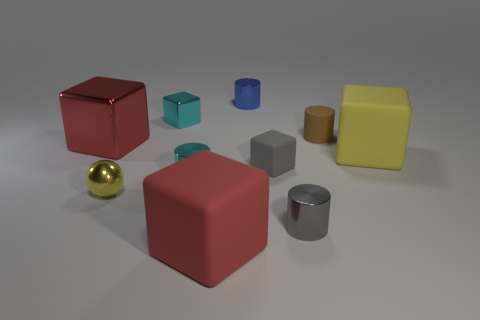Subtract all yellow cylinders. How many red cubes are left? 2 Subtract all small metallic cubes. How many cubes are left? 4 Subtract all blue cylinders. How many cylinders are left? 3 Subtract all cylinders. How many objects are left? 6 Subtract all blue cubes. Subtract all yellow spheres. How many cubes are left? 5 Subtract all red metallic blocks. Subtract all big metallic objects. How many objects are left? 8 Add 6 cyan cylinders. How many cyan cylinders are left? 7 Add 2 big red rubber cubes. How many big red rubber cubes exist? 3 Subtract 0 green balls. How many objects are left? 10 